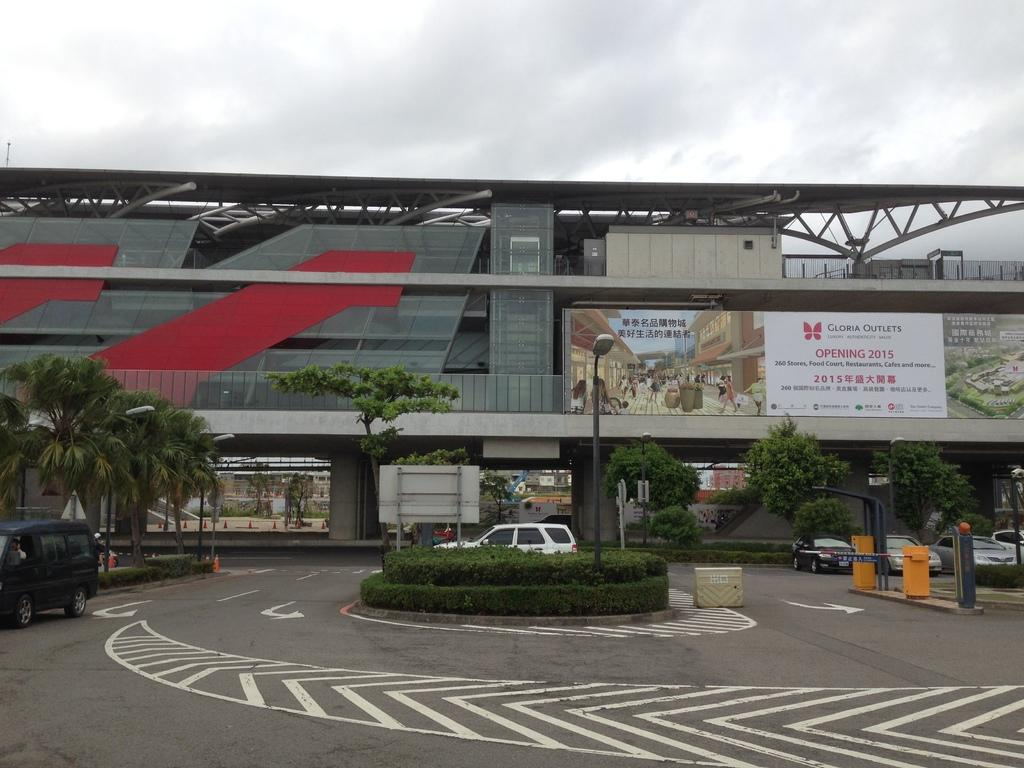What type of structure is visible in the image? There is a building in the image. What can be seen in front of the building? There are trees and lamp posts in front of the building. What type of vehicles are parked in the image? Cars are parked in the image. What type of insurance is being advertised on the church in the image? There is no church present in the image, and therefore no insurance advertisement can be observed. 